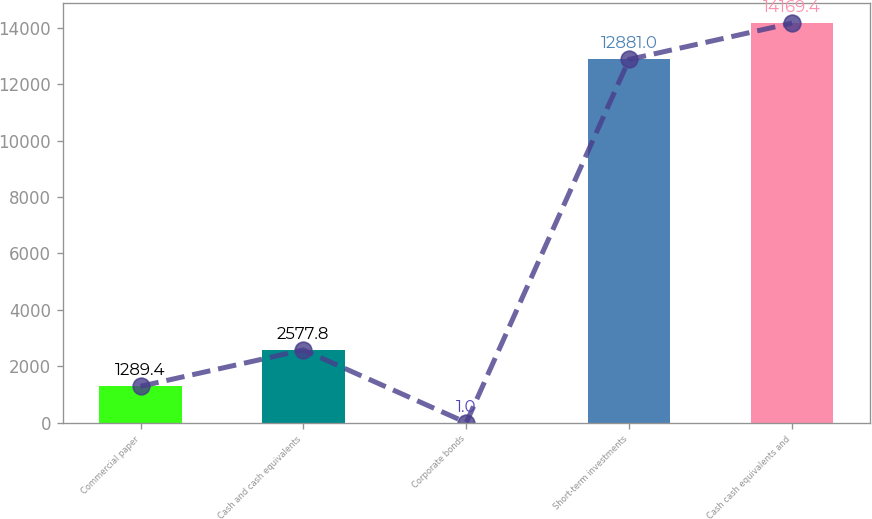<chart> <loc_0><loc_0><loc_500><loc_500><bar_chart><fcel>Commercial paper<fcel>Cash and cash equivalents<fcel>Corporate bonds<fcel>Short-term investments<fcel>Cash cash equivalents and<nl><fcel>1289.4<fcel>2577.8<fcel>1<fcel>12881<fcel>14169.4<nl></chart> 